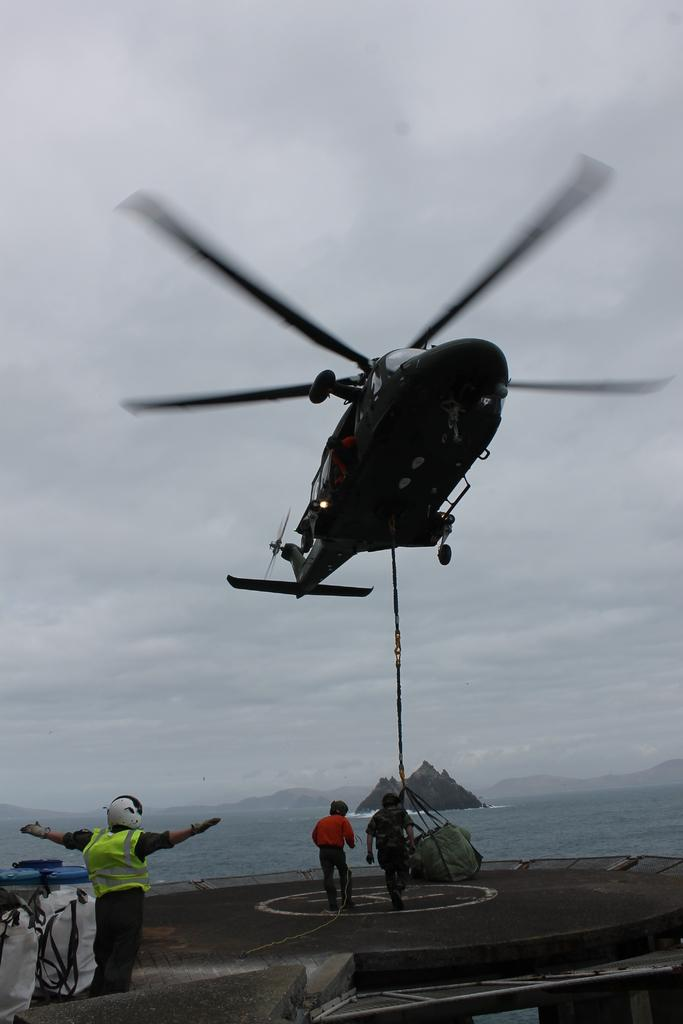What is the main subject of the image? The main subject of the image is a helicopter. What is the helicopter doing in the image? The helicopter is flying in the image. Is there any equipment or accessory associated with the helicopter? Yes, there is a bag associated with the helicopter. What can be seen in the background of the image? The sky with clouds, water, hills, and persons standing on the road are visible in the background. How do the persons standing on the road balance the helicopter in the image? The persons standing on the road are not balancing the helicopter in the image; they are simply standing on the road in the background. What type of wash is being used to clean the helicopter in the image? There is no wash being used to clean the helicopter in the image; it is flying in the air. 